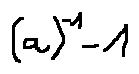<formula> <loc_0><loc_0><loc_500><loc_500>( a ) ^ { - 1 } - 1</formula> 